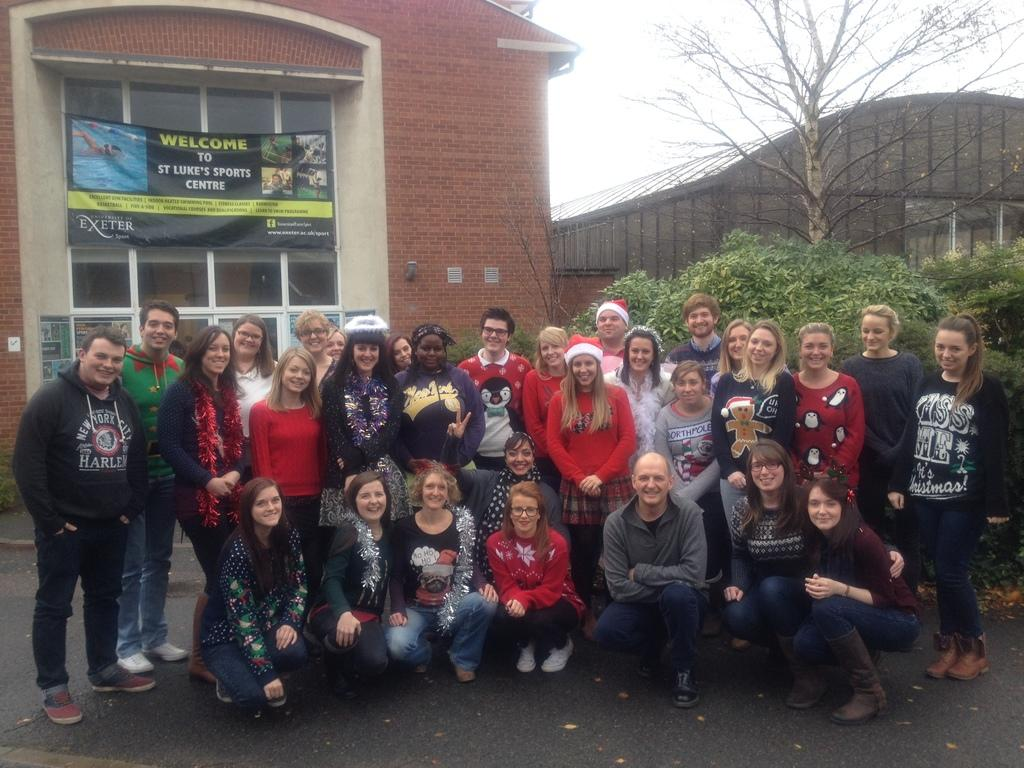What is the main focus of the image? The main focus of the image is the people in the center. What can be seen in the background of the image? In the background of the image, there are buildings, posters, greenery, and the sky. Can you describe the setting of the image? The image is set in an area with buildings, posters, greenery, and the sky visible in the background. What type of caption is written on the baseball in the image? There is no baseball present in the image, so there is no caption to be read. 